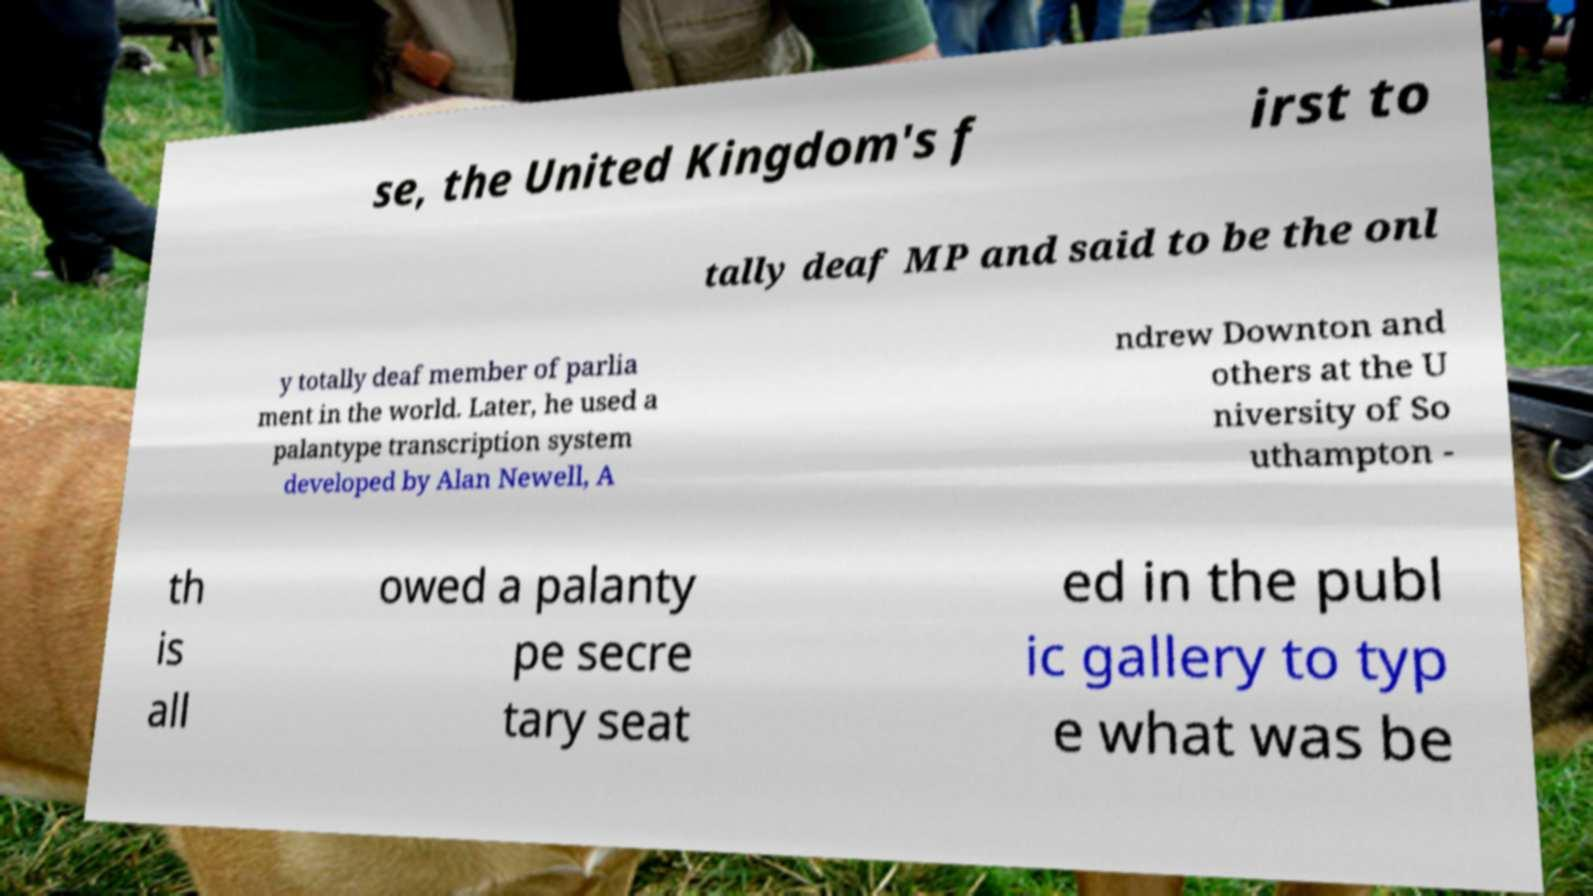I need the written content from this picture converted into text. Can you do that? se, the United Kingdom's f irst to tally deaf MP and said to be the onl y totally deaf member of parlia ment in the world. Later, he used a palantype transcription system developed by Alan Newell, A ndrew Downton and others at the U niversity of So uthampton - th is all owed a palanty pe secre tary seat ed in the publ ic gallery to typ e what was be 